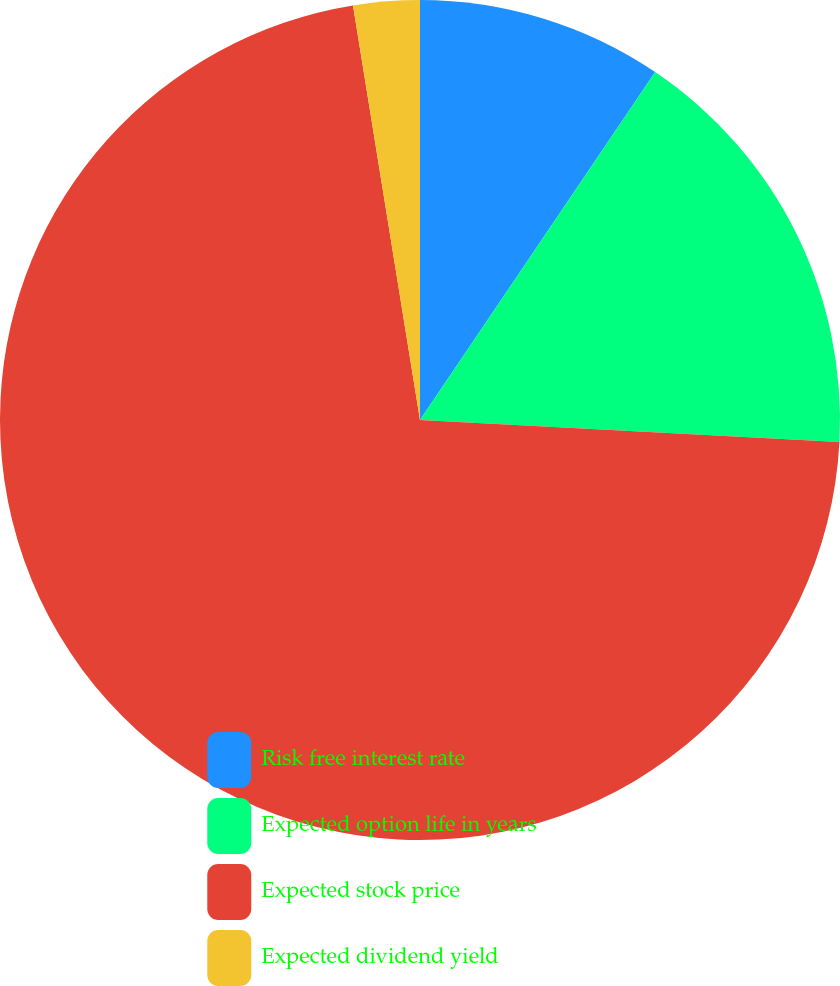<chart> <loc_0><loc_0><loc_500><loc_500><pie_chart><fcel>Risk free interest rate<fcel>Expected option life in years<fcel>Expected stock price<fcel>Expected dividend yield<nl><fcel>9.46%<fcel>16.37%<fcel>71.62%<fcel>2.55%<nl></chart> 